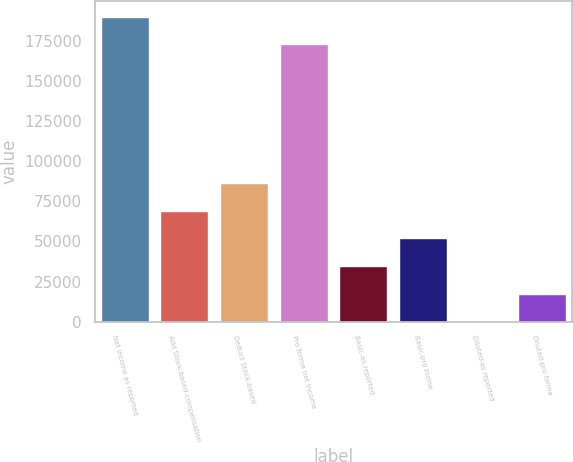<chart> <loc_0><loc_0><loc_500><loc_500><bar_chart><fcel>Net income as reported<fcel>Add Stock-based compensation<fcel>Deduct Stock-based<fcel>Pro forma net income<fcel>Basic-as reported<fcel>Basic-pro forma<fcel>Diluted-as reported<fcel>Diluted-pro forma<nl><fcel>190047<fcel>69223.5<fcel>86529.1<fcel>172741<fcel>34612.3<fcel>51917.9<fcel>1.12<fcel>17306.7<nl></chart> 